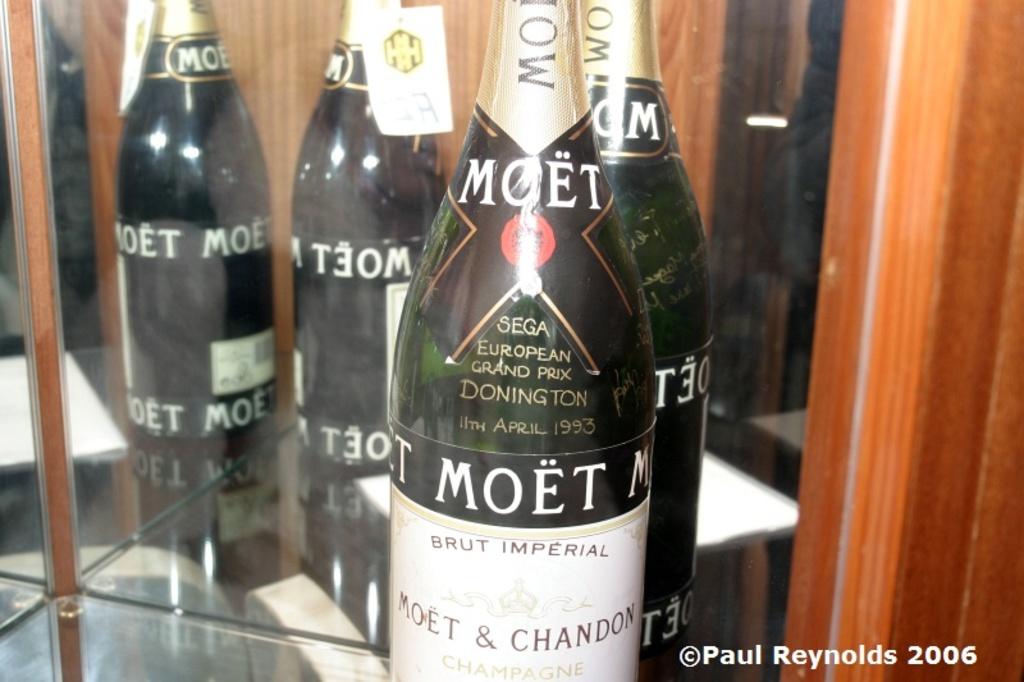What sega grand prix race year does this bottle of champagne celebrate?
Offer a terse response. 1993. What is the name of the beverage?
Make the answer very short. Moet. 